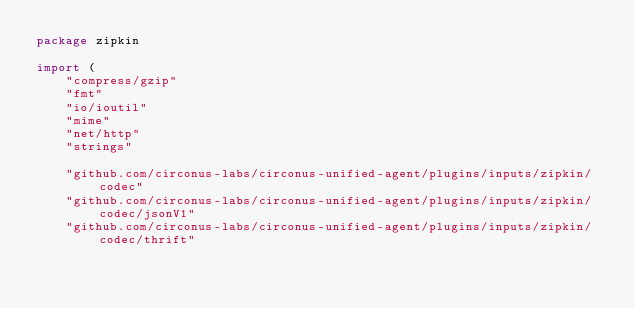Convert code to text. <code><loc_0><loc_0><loc_500><loc_500><_Go_>package zipkin

import (
	"compress/gzip"
	"fmt"
	"io/ioutil"
	"mime"
	"net/http"
	"strings"

	"github.com/circonus-labs/circonus-unified-agent/plugins/inputs/zipkin/codec"
	"github.com/circonus-labs/circonus-unified-agent/plugins/inputs/zipkin/codec/jsonV1"
	"github.com/circonus-labs/circonus-unified-agent/plugins/inputs/zipkin/codec/thrift"</code> 